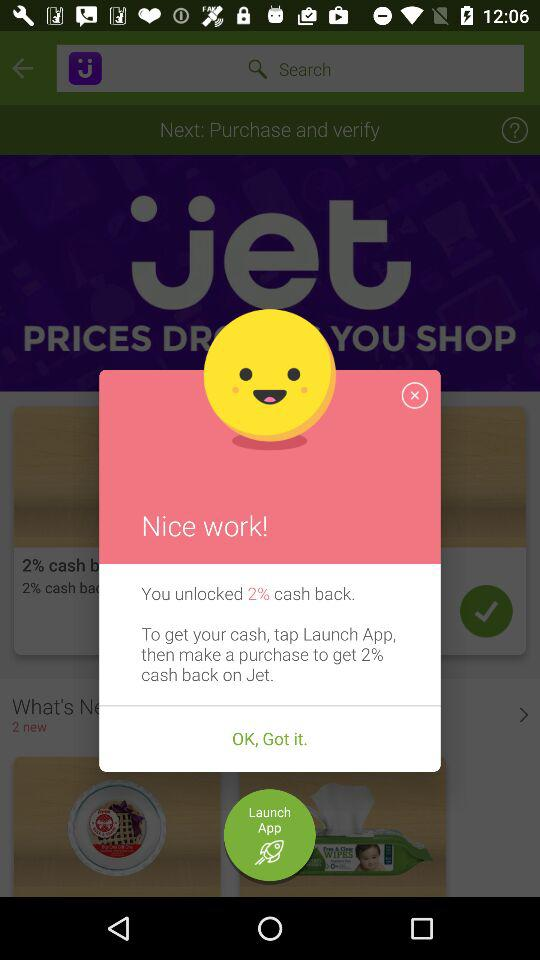When will the next purchase be delivered?
When the provided information is insufficient, respond with <no answer>. <no answer> 